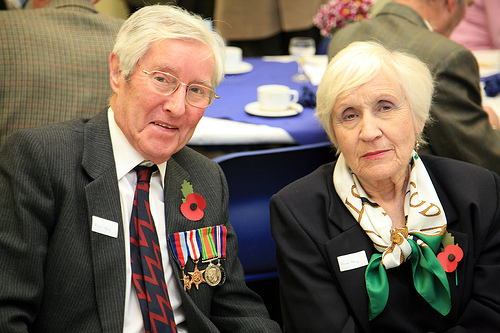<image>
Can you confirm if the cat is behind the mouse? No. The cat is not behind the mouse. From this viewpoint, the cat appears to be positioned elsewhere in the scene. Where is the medals in relation to the senior? Is it on the senior? Yes. Looking at the image, I can see the medals is positioned on top of the senior, with the senior providing support. Is the tie on the woman? No. The tie is not positioned on the woman. They may be near each other, but the tie is not supported by or resting on top of the woman. 